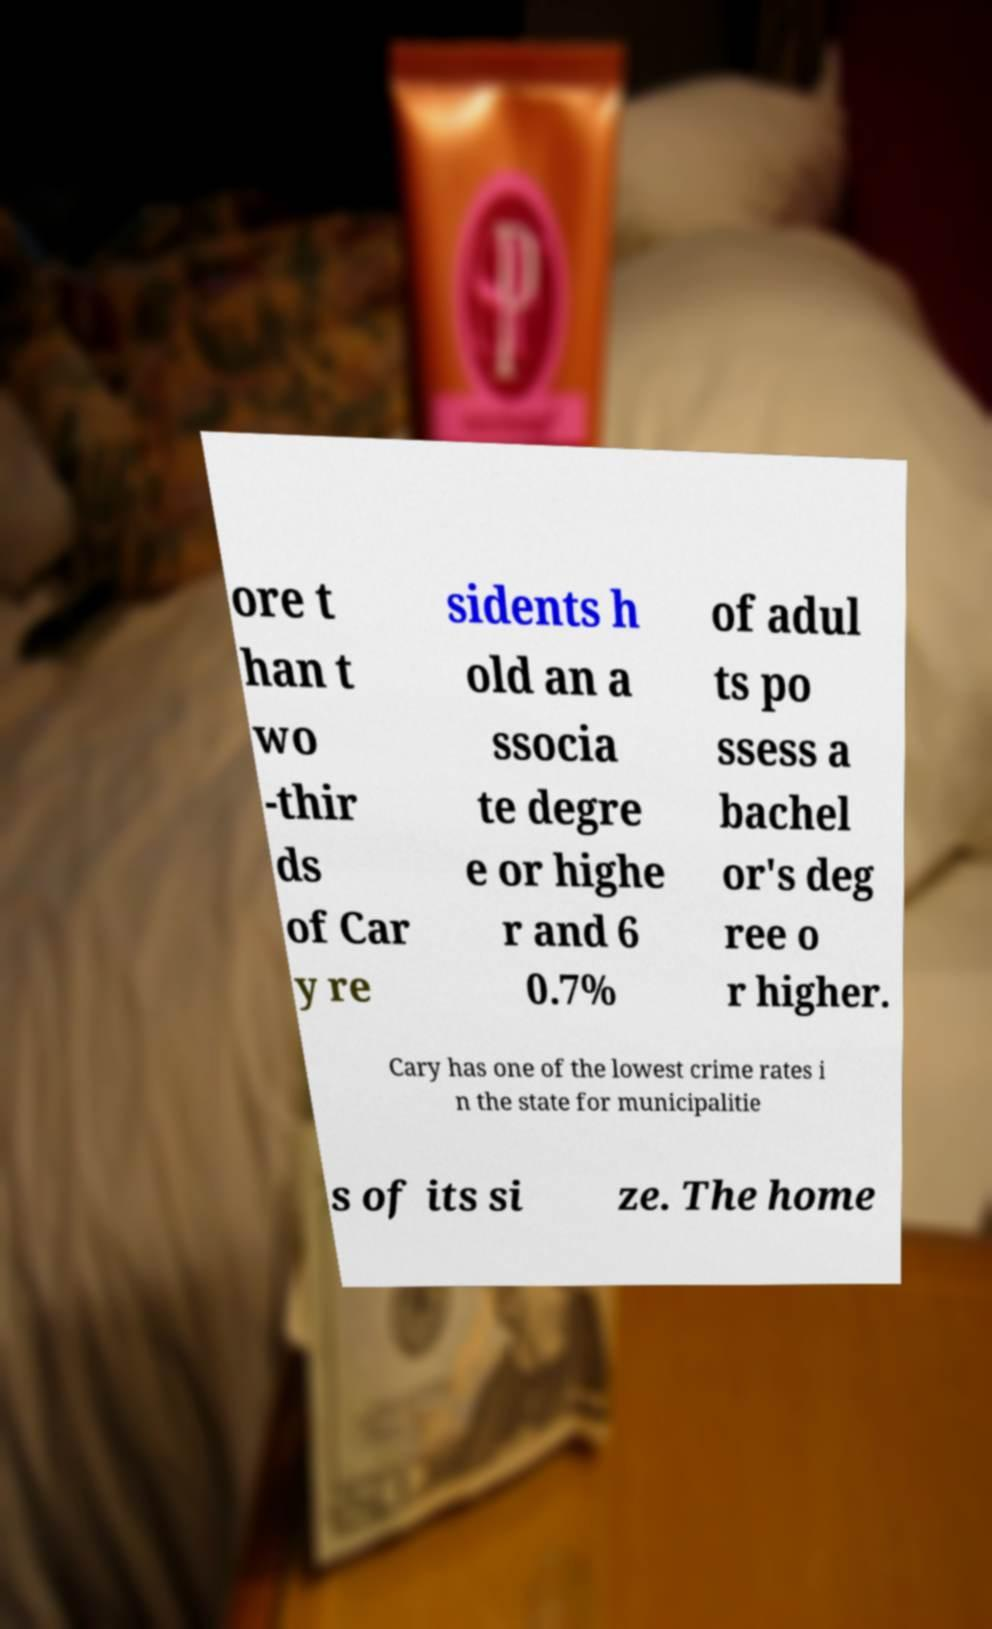Can you read and provide the text displayed in the image?This photo seems to have some interesting text. Can you extract and type it out for me? ore t han t wo -thir ds of Car y re sidents h old an a ssocia te degre e or highe r and 6 0.7% of adul ts po ssess a bachel or's deg ree o r higher. Cary has one of the lowest crime rates i n the state for municipalitie s of its si ze. The home 